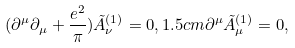Convert formula to latex. <formula><loc_0><loc_0><loc_500><loc_500>( \partial ^ { \mu } \partial _ { \mu } + \frac { e ^ { 2 } } { \pi } ) \tilde { A } _ { \nu } ^ { ( 1 ) } = 0 , 1 . 5 c m \partial ^ { \mu } \tilde { A } _ { \mu } ^ { ( 1 ) } = 0 ,</formula> 